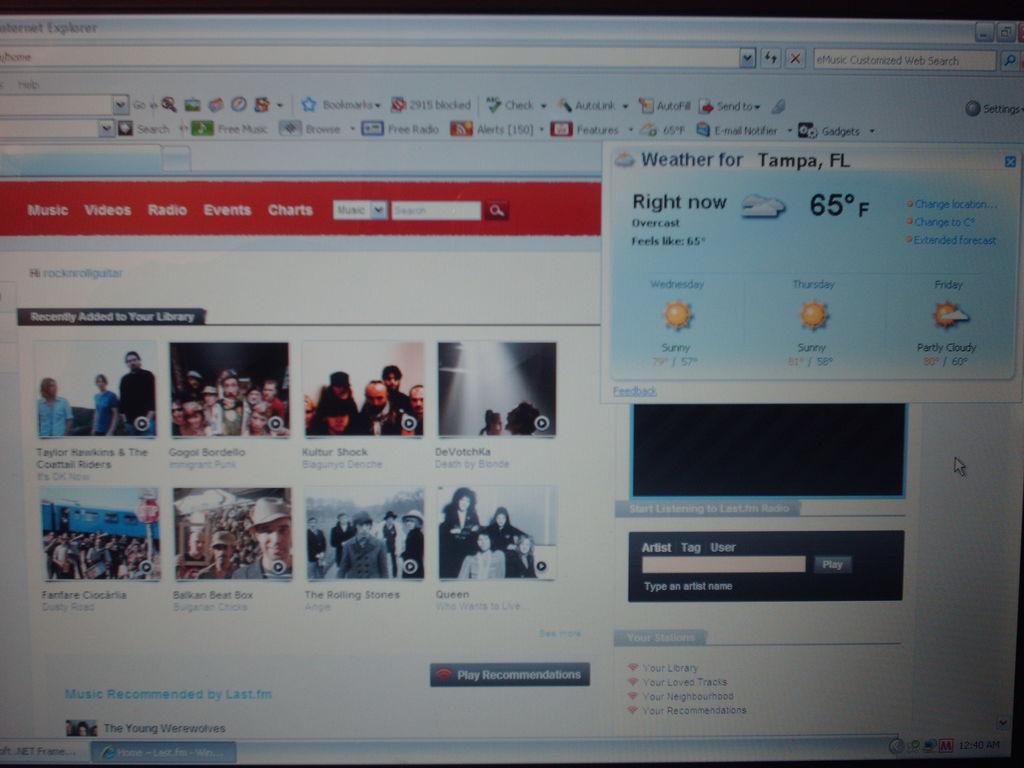What is the temperature right now?
Keep it short and to the point. 65 degrees. What location is temperature shown for?
Keep it short and to the point. Tampa, fl. 